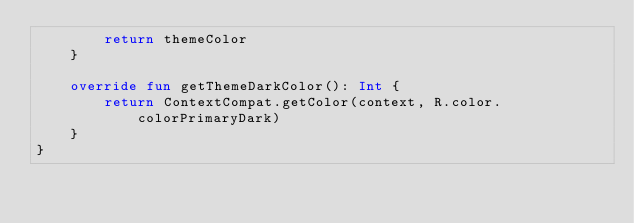Convert code to text. <code><loc_0><loc_0><loc_500><loc_500><_Kotlin_>        return themeColor
    }

    override fun getThemeDarkColor(): Int {
        return ContextCompat.getColor(context, R.color.colorPrimaryDark)
    }
}
</code> 